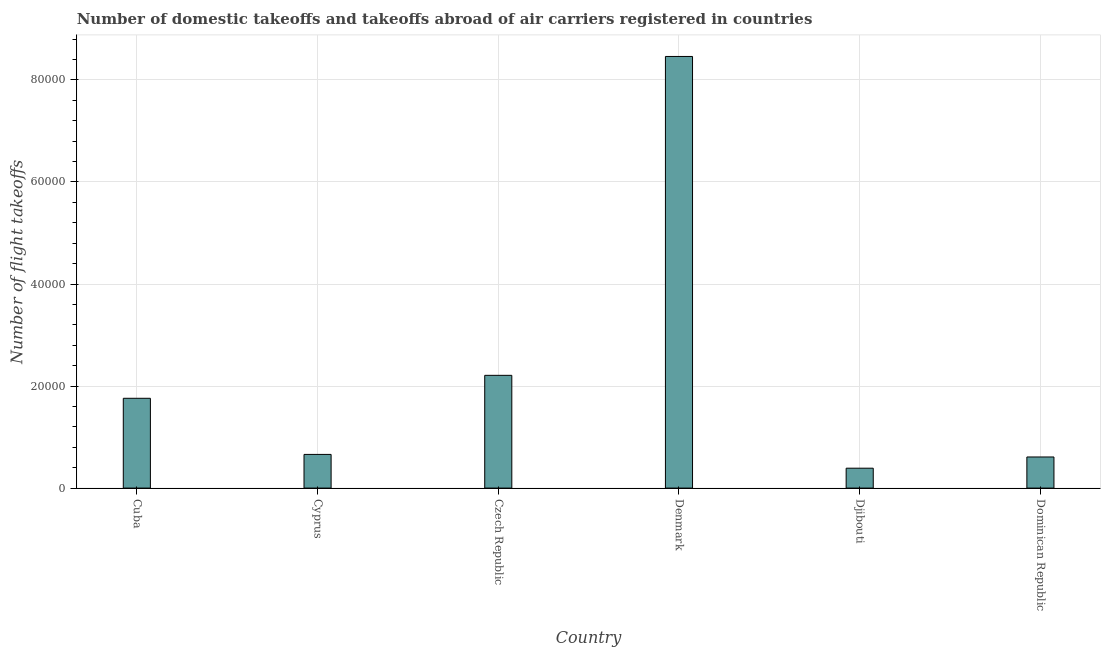Does the graph contain grids?
Offer a terse response. Yes. What is the title of the graph?
Provide a succinct answer. Number of domestic takeoffs and takeoffs abroad of air carriers registered in countries. What is the label or title of the Y-axis?
Provide a short and direct response. Number of flight takeoffs. What is the number of flight takeoffs in Denmark?
Provide a short and direct response. 8.46e+04. Across all countries, what is the maximum number of flight takeoffs?
Your response must be concise. 8.46e+04. Across all countries, what is the minimum number of flight takeoffs?
Give a very brief answer. 3900. In which country was the number of flight takeoffs maximum?
Your response must be concise. Denmark. In which country was the number of flight takeoffs minimum?
Provide a short and direct response. Djibouti. What is the sum of the number of flight takeoffs?
Provide a short and direct response. 1.41e+05. What is the difference between the number of flight takeoffs in Czech Republic and Djibouti?
Ensure brevity in your answer.  1.82e+04. What is the average number of flight takeoffs per country?
Make the answer very short. 2.35e+04. What is the median number of flight takeoffs?
Provide a short and direct response. 1.21e+04. What is the ratio of the number of flight takeoffs in Czech Republic to that in Denmark?
Offer a very short reply. 0.26. Is the difference between the number of flight takeoffs in Cuba and Dominican Republic greater than the difference between any two countries?
Your answer should be compact. No. What is the difference between the highest and the second highest number of flight takeoffs?
Your answer should be very brief. 6.25e+04. Is the sum of the number of flight takeoffs in Cuba and Czech Republic greater than the maximum number of flight takeoffs across all countries?
Your answer should be very brief. No. What is the difference between the highest and the lowest number of flight takeoffs?
Keep it short and to the point. 8.07e+04. Are all the bars in the graph horizontal?
Your response must be concise. No. What is the Number of flight takeoffs of Cuba?
Make the answer very short. 1.76e+04. What is the Number of flight takeoffs in Cyprus?
Keep it short and to the point. 6600. What is the Number of flight takeoffs in Czech Republic?
Offer a very short reply. 2.21e+04. What is the Number of flight takeoffs in Denmark?
Offer a very short reply. 8.46e+04. What is the Number of flight takeoffs of Djibouti?
Your answer should be very brief. 3900. What is the Number of flight takeoffs of Dominican Republic?
Your answer should be compact. 6100. What is the difference between the Number of flight takeoffs in Cuba and Cyprus?
Your answer should be compact. 1.10e+04. What is the difference between the Number of flight takeoffs in Cuba and Czech Republic?
Your answer should be very brief. -4500. What is the difference between the Number of flight takeoffs in Cuba and Denmark?
Ensure brevity in your answer.  -6.70e+04. What is the difference between the Number of flight takeoffs in Cuba and Djibouti?
Your response must be concise. 1.37e+04. What is the difference between the Number of flight takeoffs in Cuba and Dominican Republic?
Make the answer very short. 1.15e+04. What is the difference between the Number of flight takeoffs in Cyprus and Czech Republic?
Your answer should be compact. -1.55e+04. What is the difference between the Number of flight takeoffs in Cyprus and Denmark?
Provide a short and direct response. -7.80e+04. What is the difference between the Number of flight takeoffs in Cyprus and Djibouti?
Your response must be concise. 2700. What is the difference between the Number of flight takeoffs in Cyprus and Dominican Republic?
Make the answer very short. 500. What is the difference between the Number of flight takeoffs in Czech Republic and Denmark?
Ensure brevity in your answer.  -6.25e+04. What is the difference between the Number of flight takeoffs in Czech Republic and Djibouti?
Offer a very short reply. 1.82e+04. What is the difference between the Number of flight takeoffs in Czech Republic and Dominican Republic?
Your answer should be very brief. 1.60e+04. What is the difference between the Number of flight takeoffs in Denmark and Djibouti?
Keep it short and to the point. 8.07e+04. What is the difference between the Number of flight takeoffs in Denmark and Dominican Republic?
Offer a terse response. 7.85e+04. What is the difference between the Number of flight takeoffs in Djibouti and Dominican Republic?
Provide a succinct answer. -2200. What is the ratio of the Number of flight takeoffs in Cuba to that in Cyprus?
Provide a short and direct response. 2.67. What is the ratio of the Number of flight takeoffs in Cuba to that in Czech Republic?
Provide a succinct answer. 0.8. What is the ratio of the Number of flight takeoffs in Cuba to that in Denmark?
Your answer should be compact. 0.21. What is the ratio of the Number of flight takeoffs in Cuba to that in Djibouti?
Make the answer very short. 4.51. What is the ratio of the Number of flight takeoffs in Cuba to that in Dominican Republic?
Provide a succinct answer. 2.88. What is the ratio of the Number of flight takeoffs in Cyprus to that in Czech Republic?
Your answer should be very brief. 0.3. What is the ratio of the Number of flight takeoffs in Cyprus to that in Denmark?
Your answer should be very brief. 0.08. What is the ratio of the Number of flight takeoffs in Cyprus to that in Djibouti?
Your answer should be very brief. 1.69. What is the ratio of the Number of flight takeoffs in Cyprus to that in Dominican Republic?
Provide a succinct answer. 1.08. What is the ratio of the Number of flight takeoffs in Czech Republic to that in Denmark?
Your answer should be very brief. 0.26. What is the ratio of the Number of flight takeoffs in Czech Republic to that in Djibouti?
Offer a terse response. 5.67. What is the ratio of the Number of flight takeoffs in Czech Republic to that in Dominican Republic?
Offer a terse response. 3.62. What is the ratio of the Number of flight takeoffs in Denmark to that in Djibouti?
Provide a succinct answer. 21.69. What is the ratio of the Number of flight takeoffs in Denmark to that in Dominican Republic?
Your response must be concise. 13.87. What is the ratio of the Number of flight takeoffs in Djibouti to that in Dominican Republic?
Offer a very short reply. 0.64. 